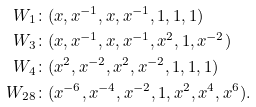Convert formula to latex. <formula><loc_0><loc_0><loc_500><loc_500>W _ { 1 } & \colon ( x , x ^ { - 1 } , x , x ^ { - 1 } , 1 , 1 , 1 ) \\ W _ { 3 } & \colon ( x , x ^ { - 1 } , x , x ^ { - 1 } , x ^ { 2 } , 1 , x ^ { - 2 } ) \\ W _ { 4 } & \colon ( x ^ { 2 } , x ^ { - 2 } , x ^ { 2 } , x ^ { - 2 } , 1 , 1 , 1 ) \\ W _ { 2 8 } & \colon ( x ^ { - 6 } , x ^ { - 4 } , x ^ { - 2 } , 1 , x ^ { 2 } , x ^ { 4 } , x ^ { 6 } ) .</formula> 